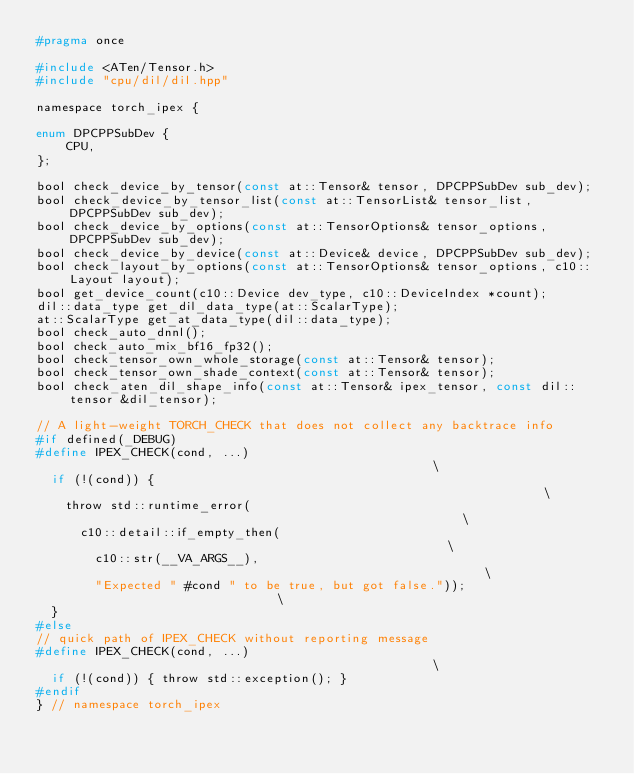Convert code to text. <code><loc_0><loc_0><loc_500><loc_500><_C_>#pragma once

#include <ATen/Tensor.h>
#include "cpu/dil/dil.hpp"

namespace torch_ipex {

enum DPCPPSubDev {
    CPU,
};

bool check_device_by_tensor(const at::Tensor& tensor, DPCPPSubDev sub_dev);
bool check_device_by_tensor_list(const at::TensorList& tensor_list, DPCPPSubDev sub_dev);
bool check_device_by_options(const at::TensorOptions& tensor_options, DPCPPSubDev sub_dev);
bool check_device_by_device(const at::Device& device, DPCPPSubDev sub_dev);
bool check_layout_by_options(const at::TensorOptions& tensor_options, c10::Layout layout);
bool get_device_count(c10::Device dev_type, c10::DeviceIndex *count);
dil::data_type get_dil_data_type(at::ScalarType);
at::ScalarType get_at_data_type(dil::data_type);
bool check_auto_dnnl();
bool check_auto_mix_bf16_fp32();
bool check_tensor_own_whole_storage(const at::Tensor& tensor);
bool check_tensor_own_shade_context(const at::Tensor& tensor);
bool check_aten_dil_shape_info(const at::Tensor& ipex_tensor, const dil::tensor &dil_tensor);

// A light-weight TORCH_CHECK that does not collect any backtrace info
#if defined(_DEBUG)
#define IPEX_CHECK(cond, ...)                                                  \
  if (!(cond)) {                                                               \
    throw std::runtime_error(                                                  \
      c10::detail::if_empty_then(                                              \
        c10::str(__VA_ARGS__),                                                 \
        "Expected " #cond " to be true, but got false."));                     \
  }
#else
// quick path of IPEX_CHECK without reporting message
#define IPEX_CHECK(cond, ...)                                                  \
  if (!(cond)) { throw std::exception(); }
#endif
} // namespace torch_ipex
</code> 